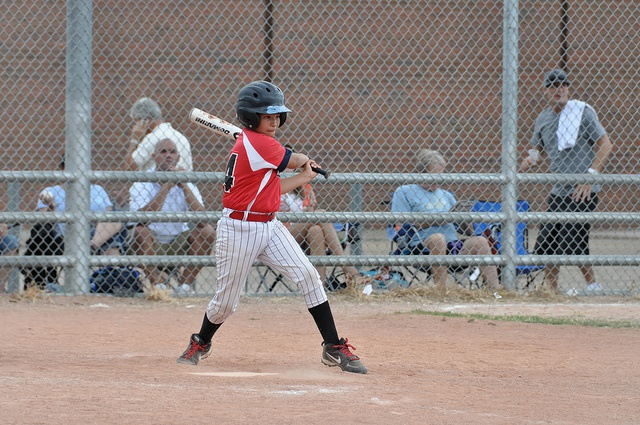Describe the objects in this image and their specific colors. I can see people in gray, darkgray, lavender, black, and brown tones, people in gray, darkgray, and black tones, people in gray, darkgray, and lightblue tones, people in gray, darkgray, and lightblue tones, and people in gray, black, darkgray, and lightblue tones in this image. 